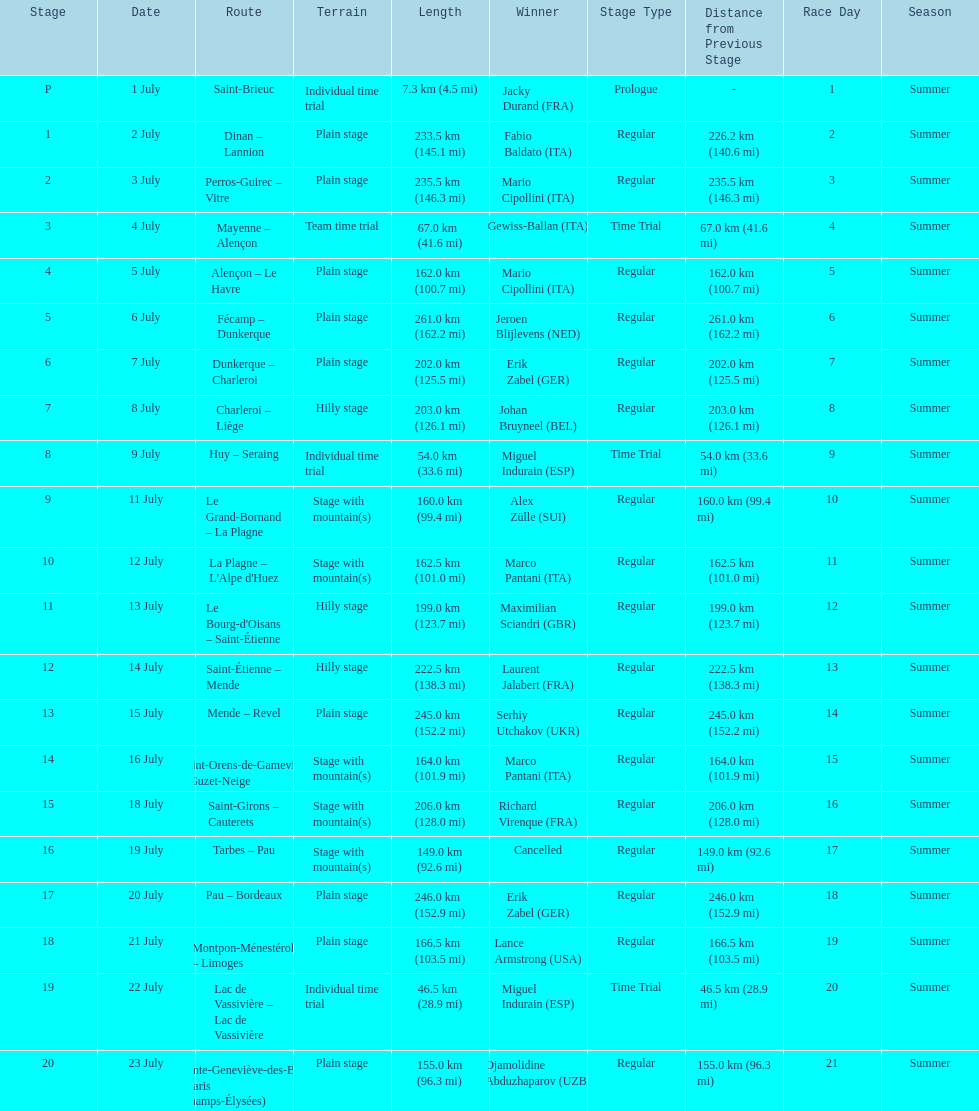After lance armstrong, who led next in the 1995 tour de france? Miguel Indurain. 